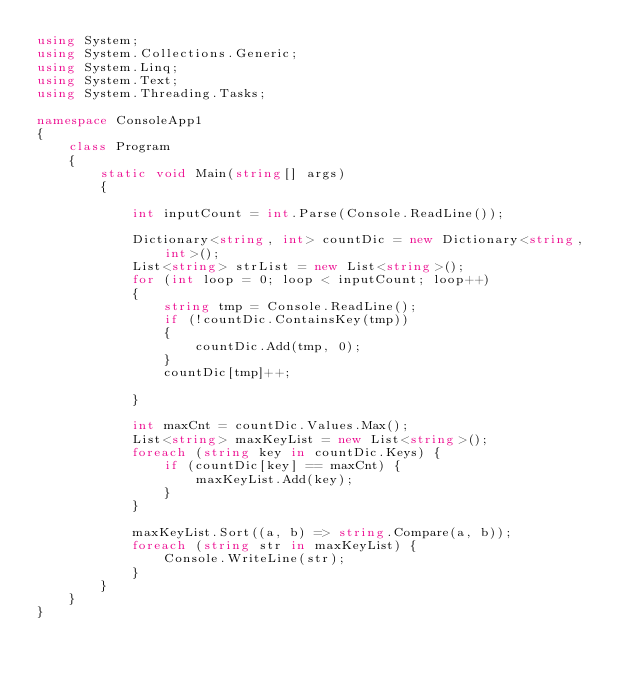Convert code to text. <code><loc_0><loc_0><loc_500><loc_500><_C#_>using System;
using System.Collections.Generic;
using System.Linq;
using System.Text;
using System.Threading.Tasks;

namespace ConsoleApp1
{
    class Program
    {
        static void Main(string[] args)
        {

            int inputCount = int.Parse(Console.ReadLine());

            Dictionary<string, int> countDic = new Dictionary<string, int>();
            List<string> strList = new List<string>();
            for (int loop = 0; loop < inputCount; loop++)
            {
                string tmp = Console.ReadLine();
                if (!countDic.ContainsKey(tmp))
                {
                    countDic.Add(tmp, 0);
                }
                countDic[tmp]++;

            }

            int maxCnt = countDic.Values.Max();
            List<string> maxKeyList = new List<string>();
            foreach (string key in countDic.Keys) {
                if (countDic[key] == maxCnt) {
                    maxKeyList.Add(key);
                }
            }

            maxKeyList.Sort((a, b) => string.Compare(a, b));
            foreach (string str in maxKeyList) {
                Console.WriteLine(str);
            }
        }
    }
}
</code> 